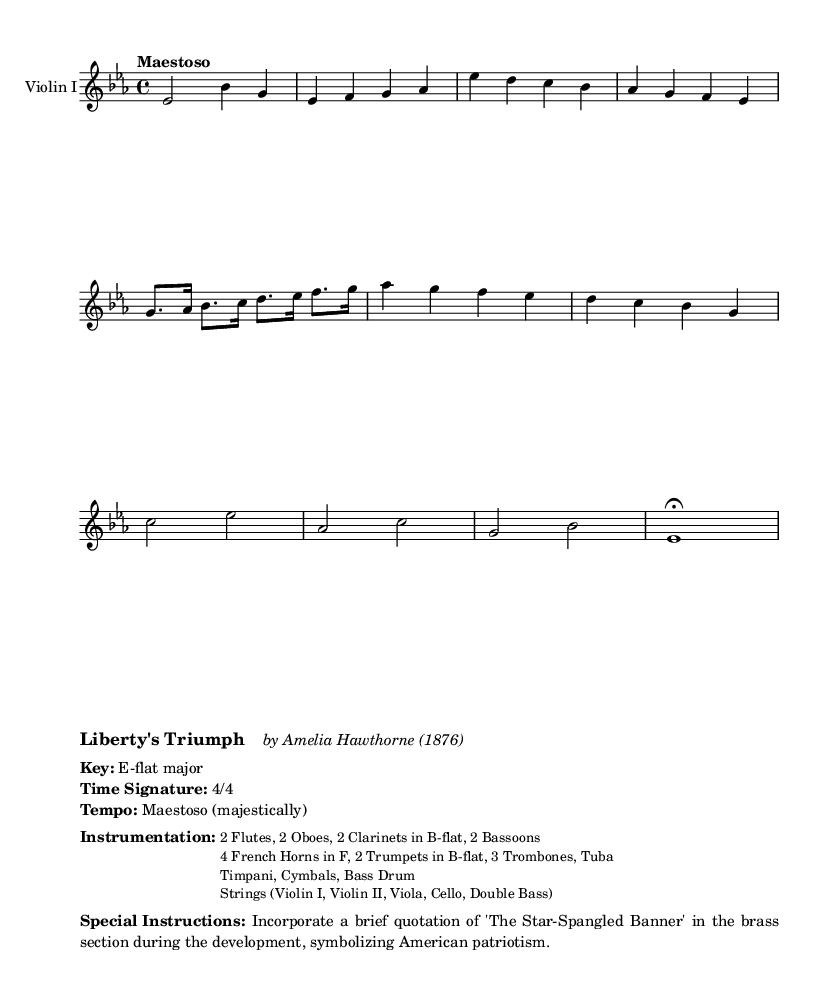What is the key signature of this music? The key signature is indicated by the two flat symbols at the beginning of the staff, which corresponds to E-flat major.
Answer: E-flat major What is the time signature of this music? The time signature is shown as a fraction with a 4 on top and a 4 on the bottom at the beginning of the staff, indicating common time (4 beats per measure).
Answer: 4/4 What is the tempo marking of this piece? The tempo marking is written directly above the staff as "Maestoso," which means to play majestically.
Answer: Maestoso How many instruments are in the brass section? By counting each type of brass instrument listed, which are 4 French Horns, 2 Trumpets, and 3 Trombones, the total adds up to 9 brass instruments.
Answer: 9 What special element is incorporated in the development section? The sheet music specifies that there is a quotation of "The Star-Spangled Banner" in the brass section during the development, signifying American patriotism.
Answer: The Star-Spangled Banner What is the overall theme represented in the title? The title "Liberty's Triumph" suggests themes of victory and patriotism, reflecting a focus on national pride associated with romantic symphonic works during the period.
Answer: Liberty's Triumph 